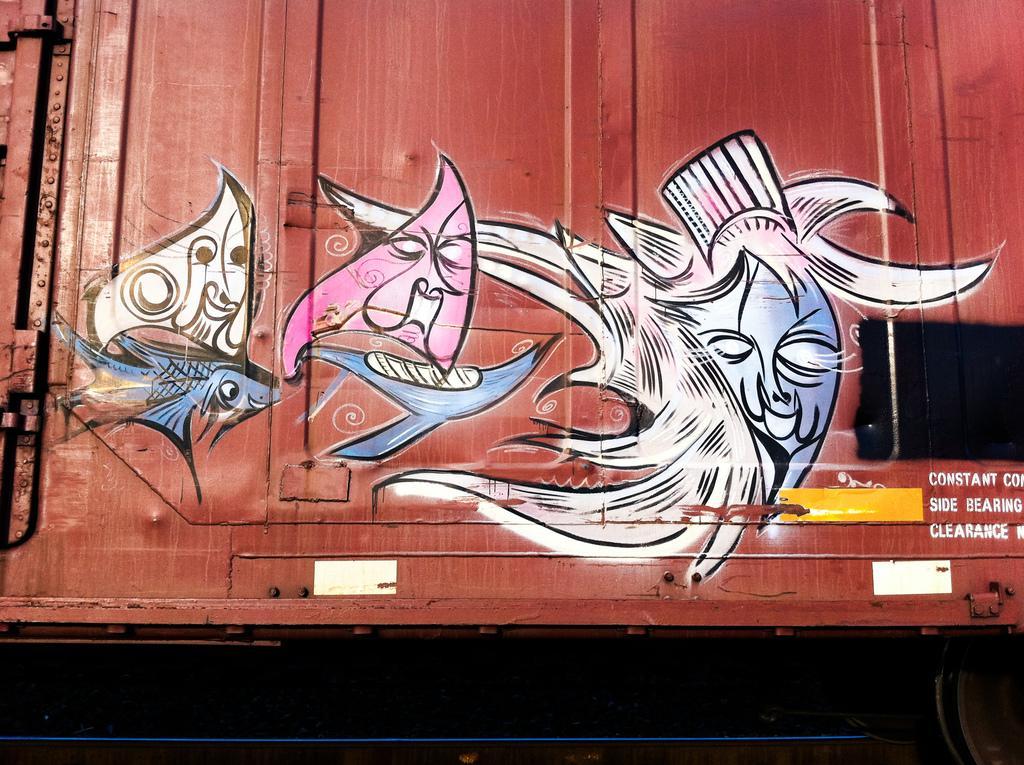Describe this image in one or two sentences. In this picture we can see a graffiti on the container. 